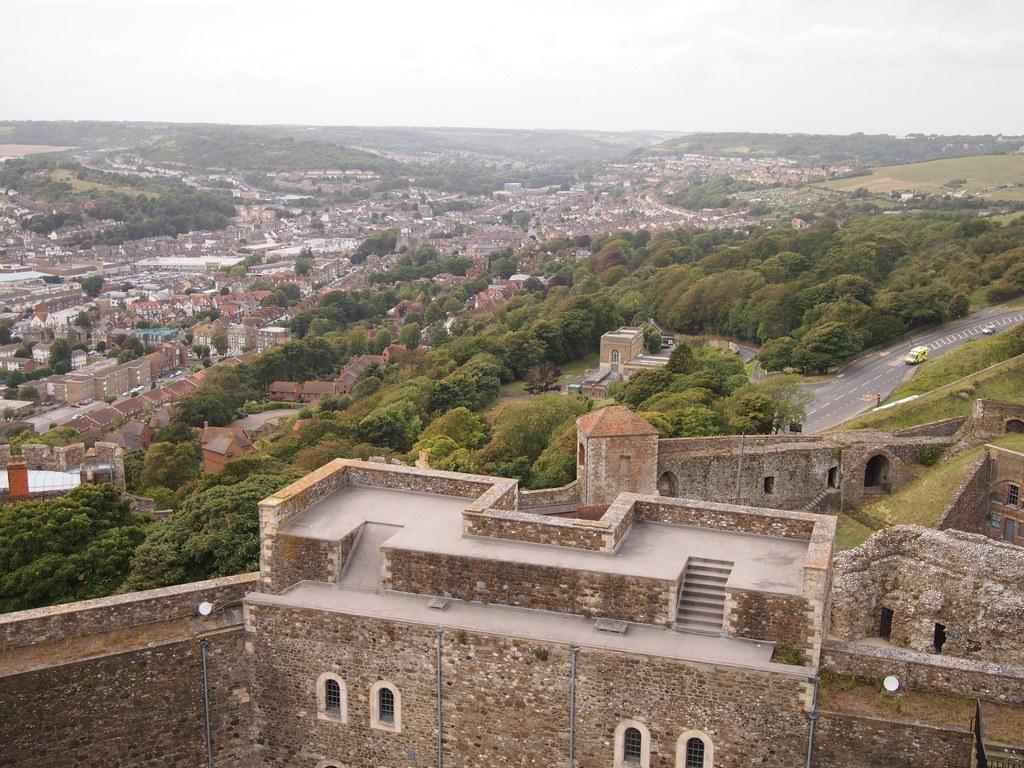In one or two sentences, can you explain what this image depicts? In this image we can see a group of buildings, houses, a group of trees, some vehicles on the ground and some grass. On the backside we can see the sky which looks cloudy. 